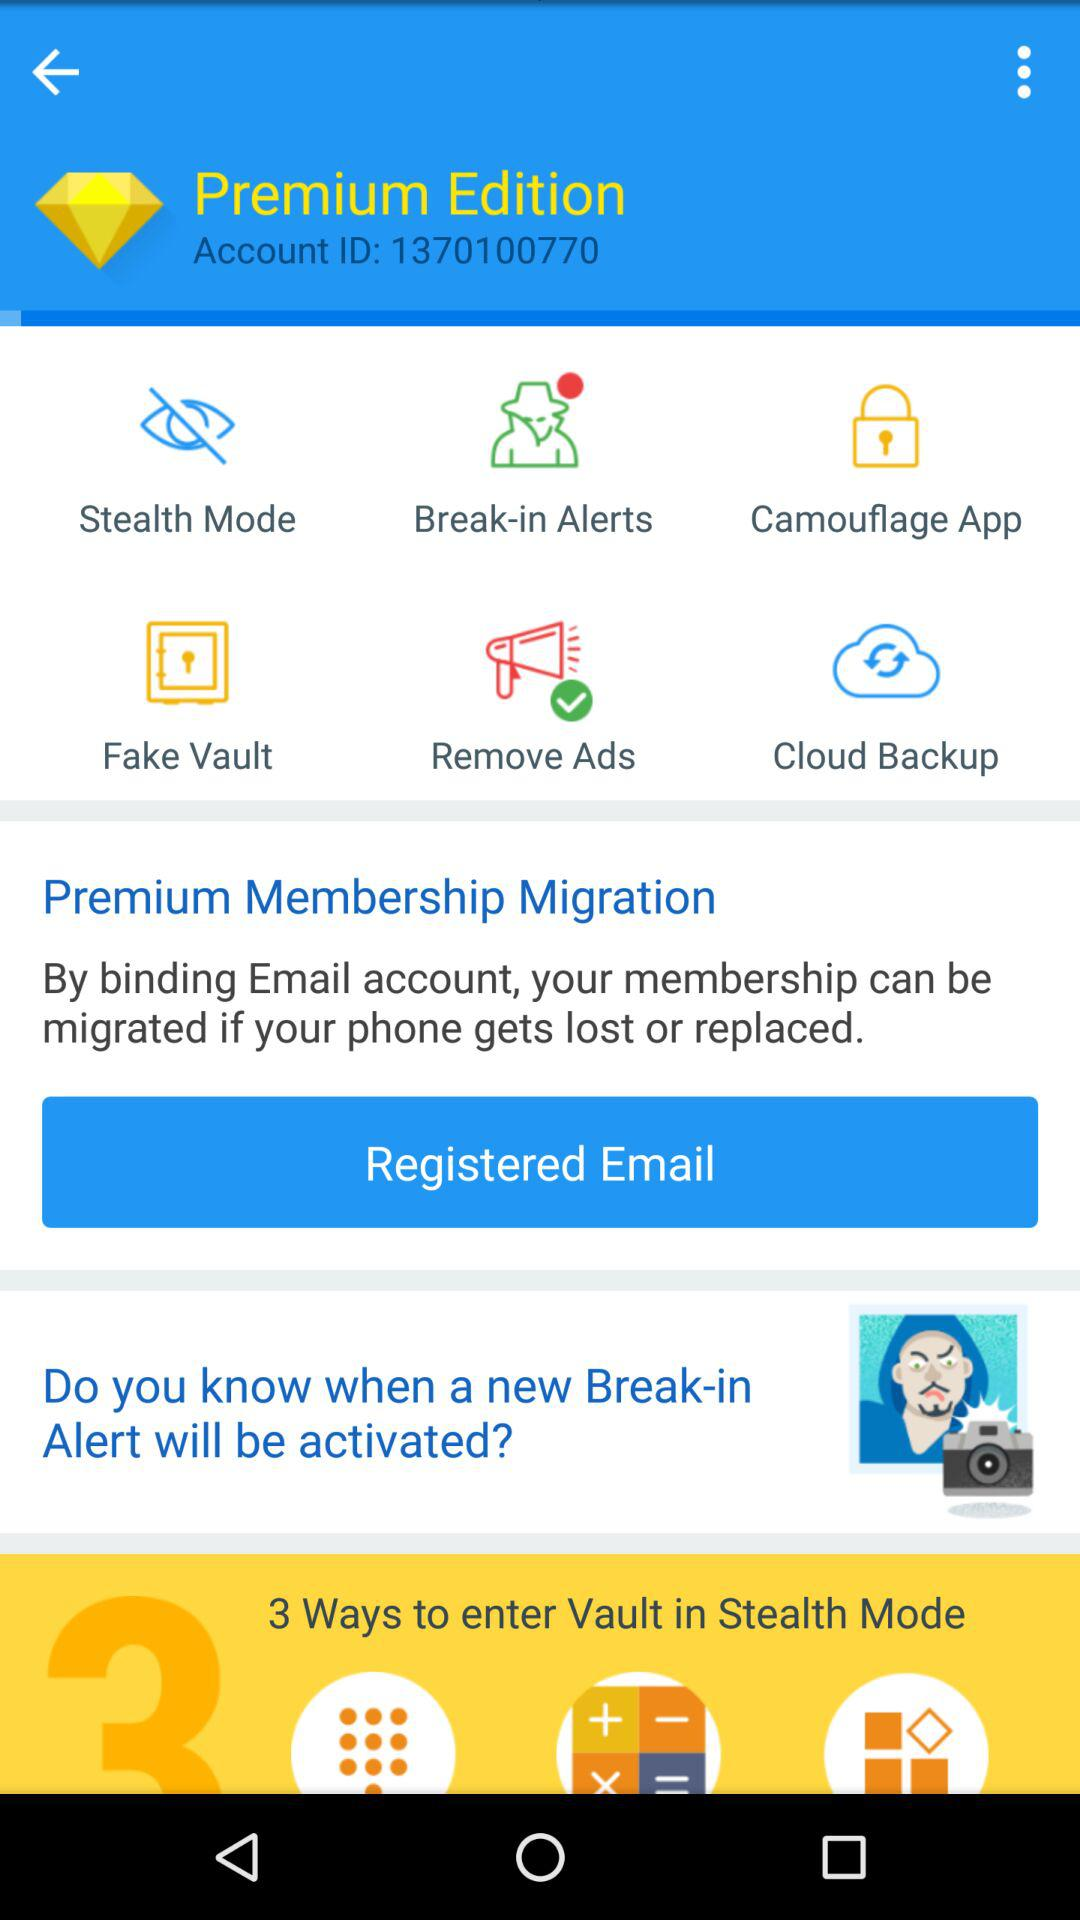What is the status of the "Remove Ads"? The status of the "Remove Ads" is still on. 